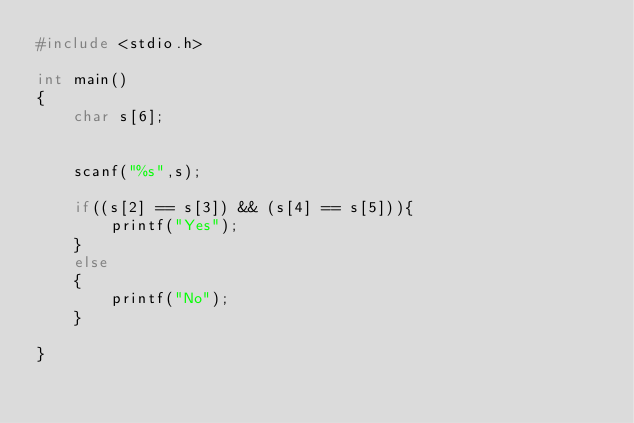<code> <loc_0><loc_0><loc_500><loc_500><_C_>#include <stdio.h>

int main()
{
    char s[6];


    scanf("%s",s);

    if((s[2] == s[3]) && (s[4] == s[5])){
        printf("Yes");
    }
    else
    {
        printf("No");
    }
    
}
</code> 